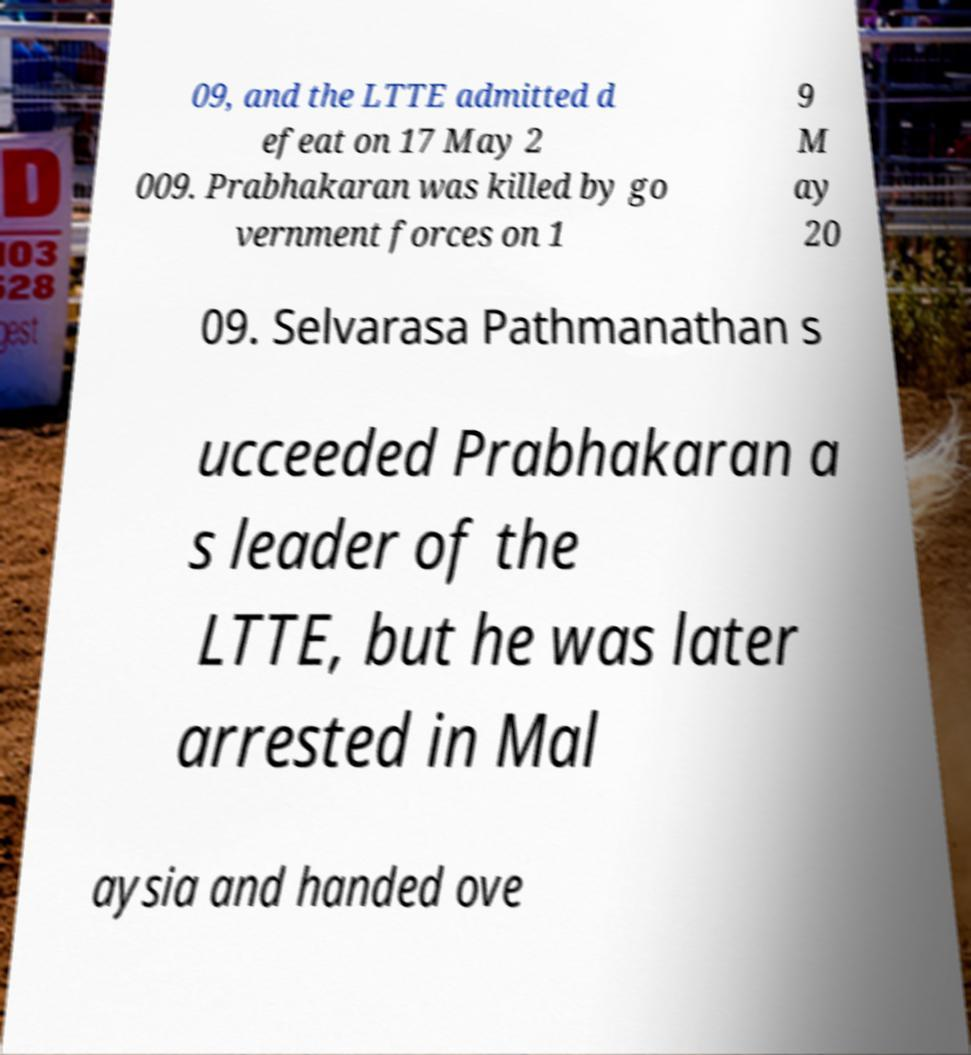What messages or text are displayed in this image? I need them in a readable, typed format. 09, and the LTTE admitted d efeat on 17 May 2 009. Prabhakaran was killed by go vernment forces on 1 9 M ay 20 09. Selvarasa Pathmanathan s ucceeded Prabhakaran a s leader of the LTTE, but he was later arrested in Mal aysia and handed ove 